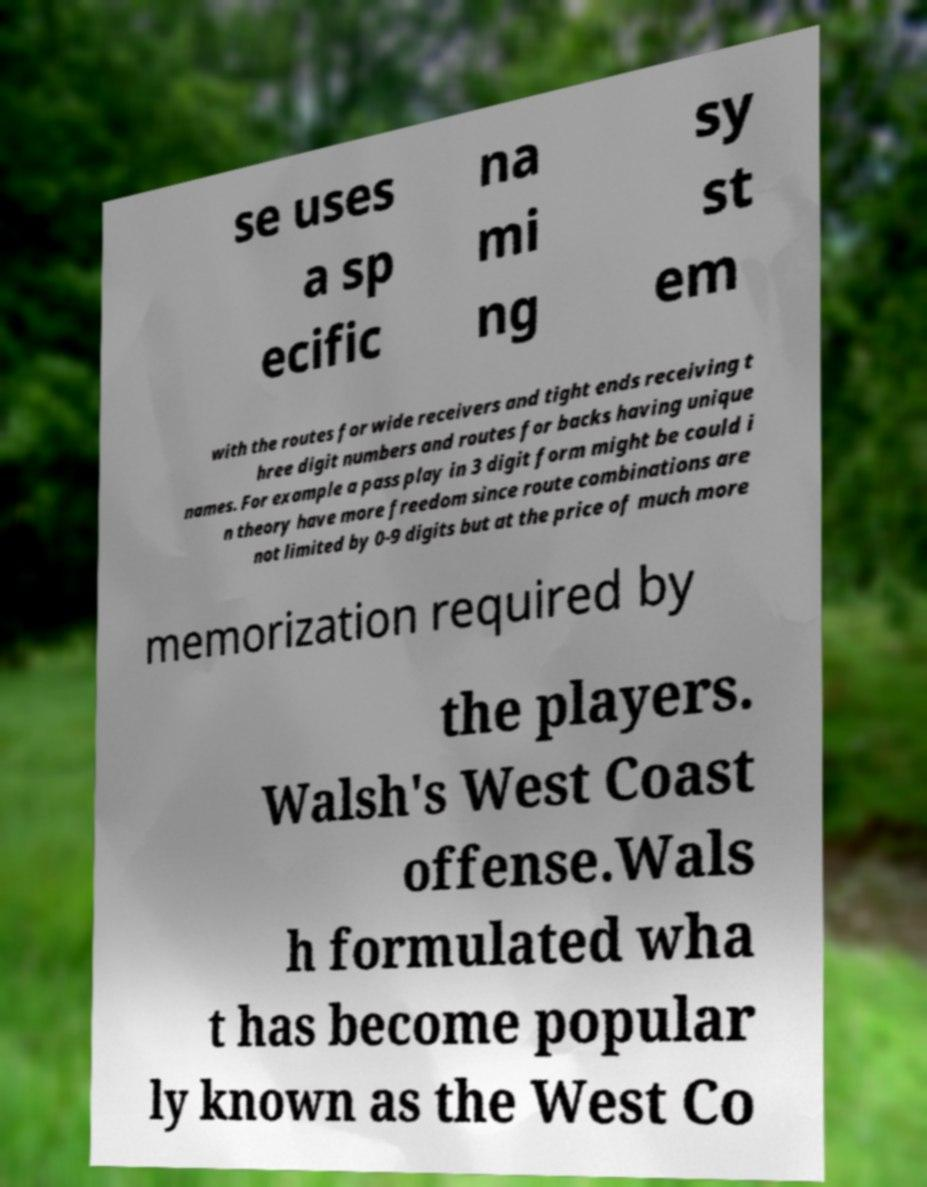Please identify and transcribe the text found in this image. se uses a sp ecific na mi ng sy st em with the routes for wide receivers and tight ends receiving t hree digit numbers and routes for backs having unique names. For example a pass play in 3 digit form might be could i n theory have more freedom since route combinations are not limited by 0-9 digits but at the price of much more memorization required by the players. Walsh's West Coast offense.Wals h formulated wha t has become popular ly known as the West Co 